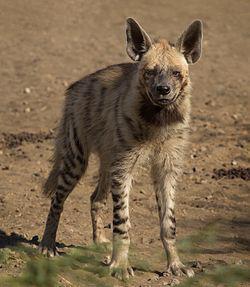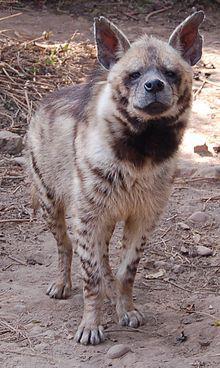The first image is the image on the left, the second image is the image on the right. Evaluate the accuracy of this statement regarding the images: "1 dog has a paw that is not touching the ground.". Is it true? Answer yes or no. No. The first image is the image on the left, the second image is the image on the right. For the images displayed, is the sentence "Two hyenas are standing and facing opposite each other." factually correct? Answer yes or no. No. 